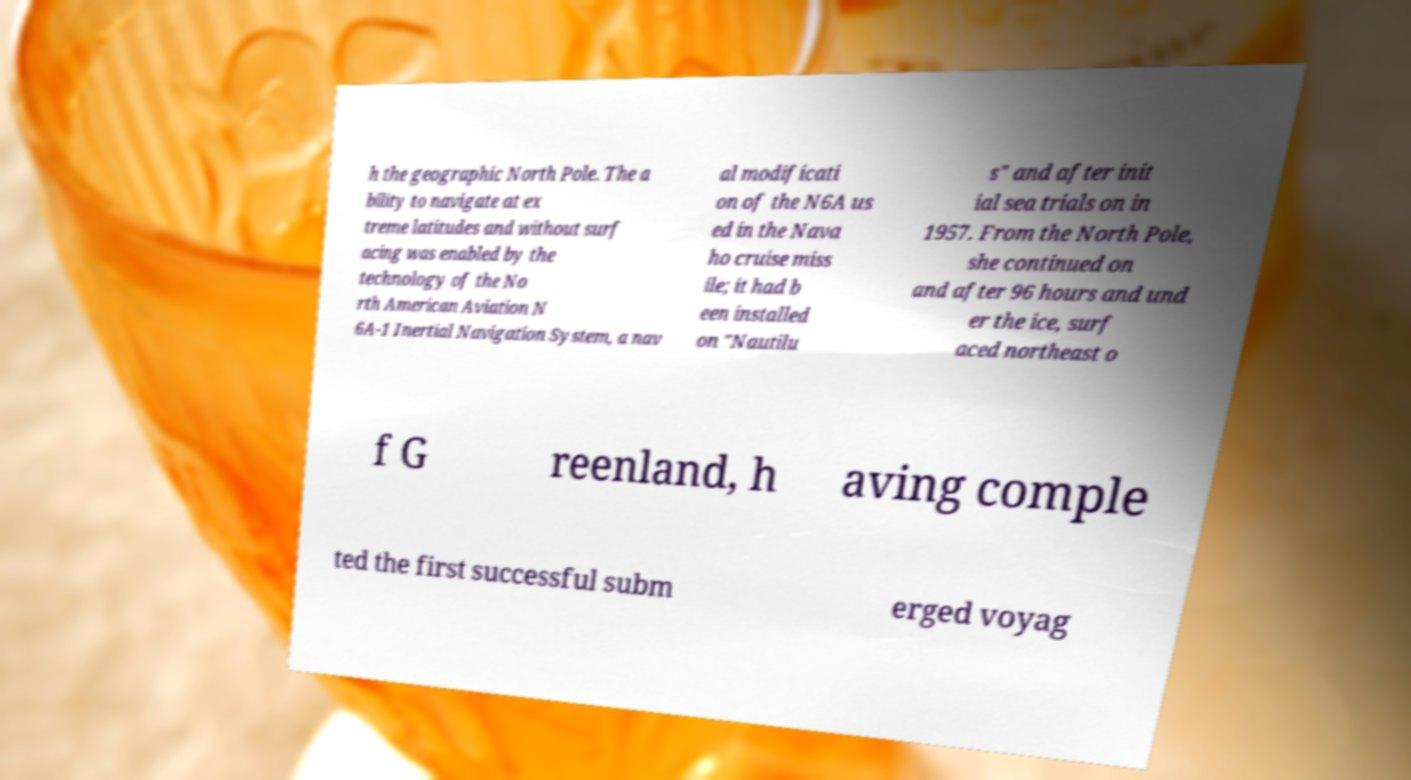For documentation purposes, I need the text within this image transcribed. Could you provide that? h the geographic North Pole. The a bility to navigate at ex treme latitudes and without surf acing was enabled by the technology of the No rth American Aviation N 6A-1 Inertial Navigation System, a nav al modificati on of the N6A us ed in the Nava ho cruise miss ile; it had b een installed on "Nautilu s" and after init ial sea trials on in 1957. From the North Pole, she continued on and after 96 hours and und er the ice, surf aced northeast o f G reenland, h aving comple ted the first successful subm erged voyag 